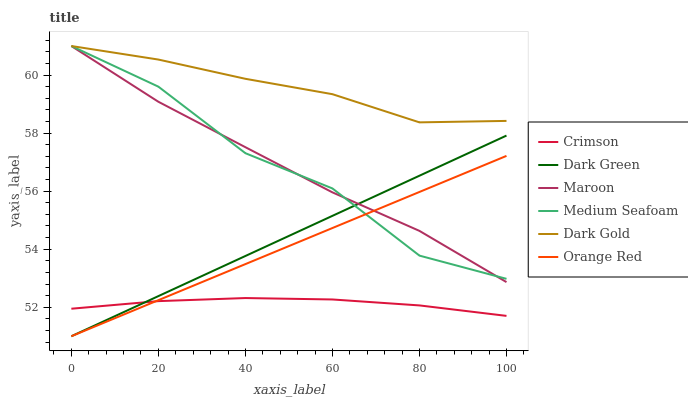Does Crimson have the minimum area under the curve?
Answer yes or no. Yes. Does Dark Gold have the maximum area under the curve?
Answer yes or no. Yes. Does Maroon have the minimum area under the curve?
Answer yes or no. No. Does Maroon have the maximum area under the curve?
Answer yes or no. No. Is Dark Green the smoothest?
Answer yes or no. Yes. Is Medium Seafoam the roughest?
Answer yes or no. Yes. Is Maroon the smoothest?
Answer yes or no. No. Is Maroon the roughest?
Answer yes or no. No. Does Orange Red have the lowest value?
Answer yes or no. Yes. Does Maroon have the lowest value?
Answer yes or no. No. Does Medium Seafoam have the highest value?
Answer yes or no. Yes. Does Crimson have the highest value?
Answer yes or no. No. Is Dark Green less than Dark Gold?
Answer yes or no. Yes. Is Dark Gold greater than Dark Green?
Answer yes or no. Yes. Does Dark Gold intersect Maroon?
Answer yes or no. Yes. Is Dark Gold less than Maroon?
Answer yes or no. No. Is Dark Gold greater than Maroon?
Answer yes or no. No. Does Dark Green intersect Dark Gold?
Answer yes or no. No. 